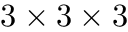Convert formula to latex. <formula><loc_0><loc_0><loc_500><loc_500>3 \times 3 \times 3</formula> 